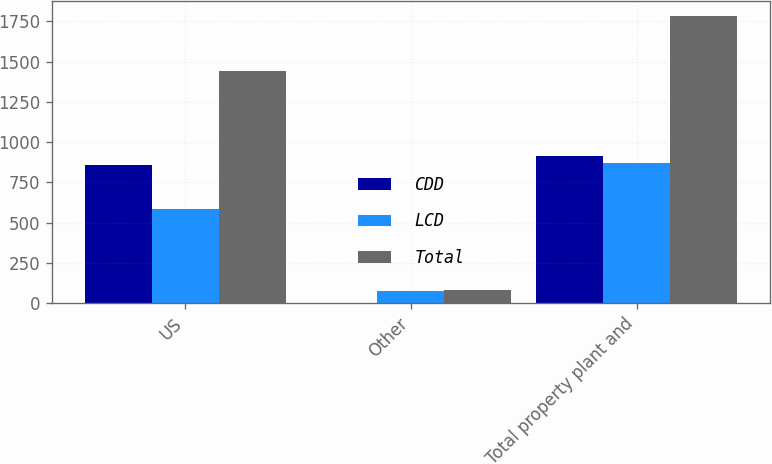Convert chart. <chart><loc_0><loc_0><loc_500><loc_500><stacked_bar_chart><ecel><fcel>US<fcel>Other<fcel>Total property plant and<nl><fcel>CDD<fcel>856.6<fcel>3.3<fcel>914.6<nl><fcel>LCD<fcel>587.1<fcel>77.5<fcel>870.1<nl><fcel>Total<fcel>1443.7<fcel>80.8<fcel>1784.7<nl></chart> 